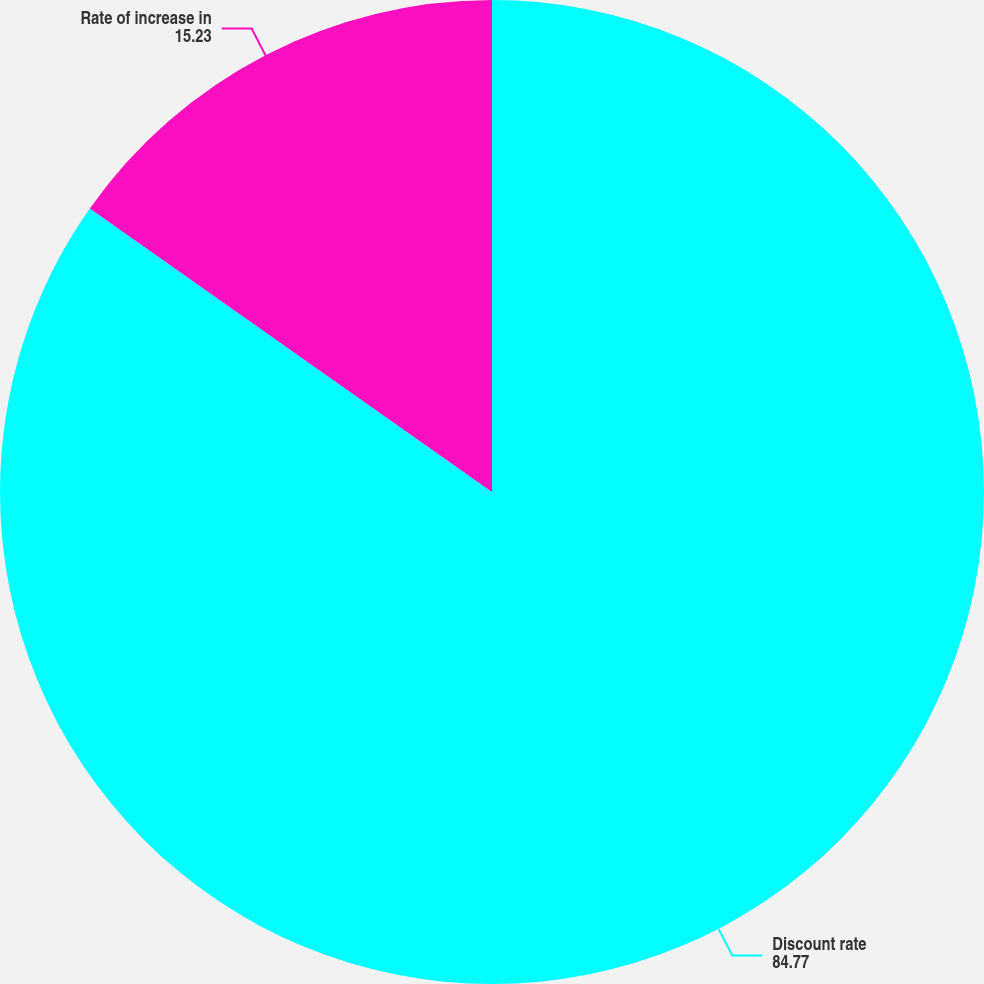Convert chart. <chart><loc_0><loc_0><loc_500><loc_500><pie_chart><fcel>Discount rate<fcel>Rate of increase in<nl><fcel>84.77%<fcel>15.23%<nl></chart> 